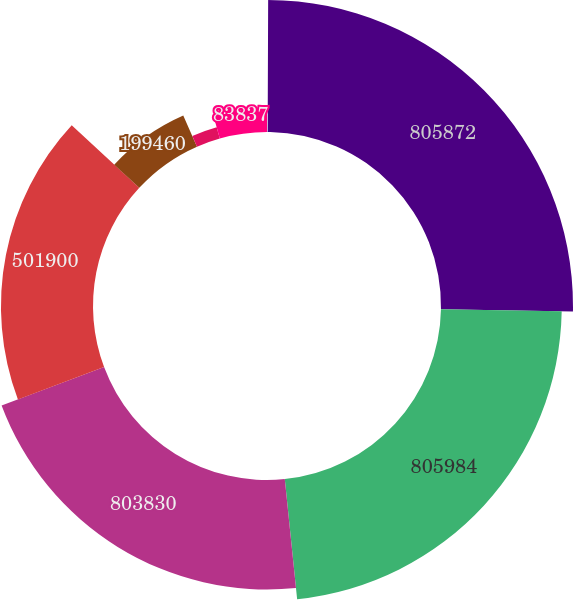Convert chart to OTSL. <chart><loc_0><loc_0><loc_500><loc_500><pie_chart><fcel>2007<fcel>805872<fcel>805984<fcel>803830<fcel>501900<fcel>199460<fcel>18633<fcel>83837<nl><fcel>0.06%<fcel>25.23%<fcel>23.08%<fcel>20.92%<fcel>17.59%<fcel>6.53%<fcel>2.22%<fcel>4.37%<nl></chart> 